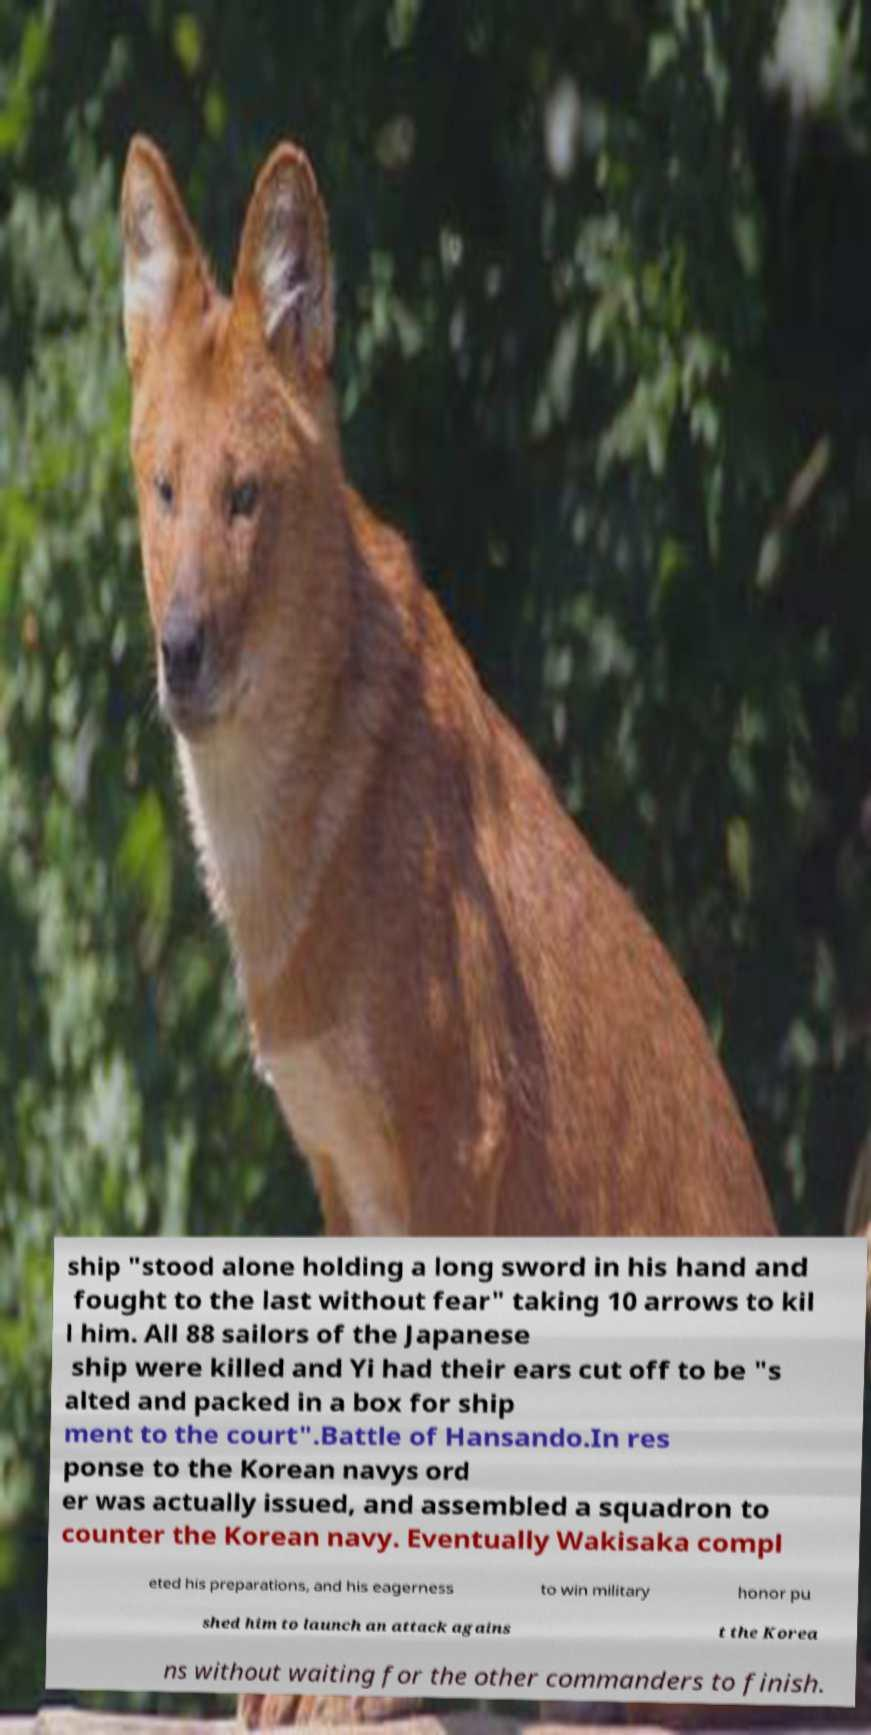For documentation purposes, I need the text within this image transcribed. Could you provide that? ship "stood alone holding a long sword in his hand and fought to the last without fear" taking 10 arrows to kil l him. All 88 sailors of the Japanese ship were killed and Yi had their ears cut off to be "s alted and packed in a box for ship ment to the court".Battle of Hansando.In res ponse to the Korean navys ord er was actually issued, and assembled a squadron to counter the Korean navy. Eventually Wakisaka compl eted his preparations, and his eagerness to win military honor pu shed him to launch an attack agains t the Korea ns without waiting for the other commanders to finish. 